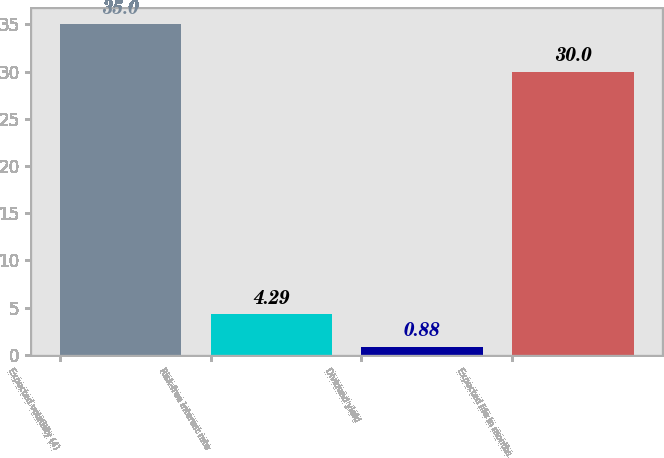<chart> <loc_0><loc_0><loc_500><loc_500><bar_chart><fcel>Expected volatility (4)<fcel>Risk-free interest rate<fcel>Dividend yield<fcel>Expected life in months<nl><fcel>35<fcel>4.29<fcel>0.88<fcel>30<nl></chart> 